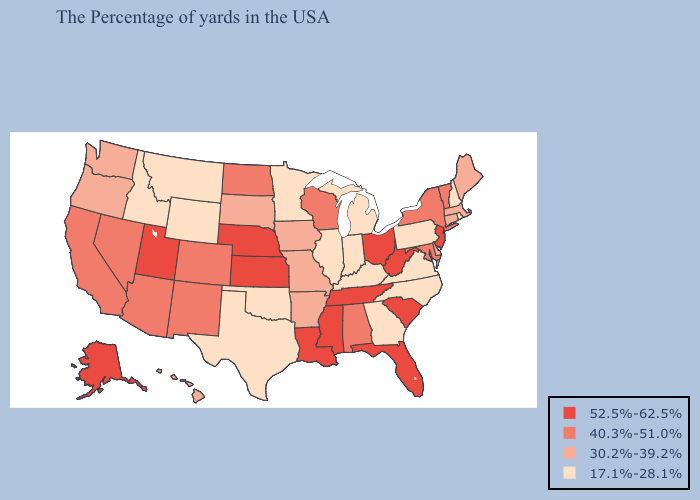Does the first symbol in the legend represent the smallest category?
Concise answer only. No. Name the states that have a value in the range 40.3%-51.0%?
Concise answer only. Vermont, New York, Maryland, Alabama, Wisconsin, North Dakota, Colorado, New Mexico, Arizona, Nevada, California. Name the states that have a value in the range 40.3%-51.0%?
Keep it brief. Vermont, New York, Maryland, Alabama, Wisconsin, North Dakota, Colorado, New Mexico, Arizona, Nevada, California. Does Indiana have the same value as Washington?
Concise answer only. No. Name the states that have a value in the range 17.1%-28.1%?
Answer briefly. Rhode Island, New Hampshire, Pennsylvania, Virginia, North Carolina, Georgia, Michigan, Kentucky, Indiana, Illinois, Minnesota, Oklahoma, Texas, Wyoming, Montana, Idaho. Name the states that have a value in the range 30.2%-39.2%?
Concise answer only. Maine, Massachusetts, Connecticut, Delaware, Missouri, Arkansas, Iowa, South Dakota, Washington, Oregon, Hawaii. Among the states that border Utah , does Wyoming have the highest value?
Quick response, please. No. What is the value of Nebraska?
Short answer required. 52.5%-62.5%. What is the value of West Virginia?
Be succinct. 52.5%-62.5%. Name the states that have a value in the range 17.1%-28.1%?
Quick response, please. Rhode Island, New Hampshire, Pennsylvania, Virginia, North Carolina, Georgia, Michigan, Kentucky, Indiana, Illinois, Minnesota, Oklahoma, Texas, Wyoming, Montana, Idaho. Name the states that have a value in the range 40.3%-51.0%?
Concise answer only. Vermont, New York, Maryland, Alabama, Wisconsin, North Dakota, Colorado, New Mexico, Arizona, Nevada, California. What is the value of Utah?
Concise answer only. 52.5%-62.5%. Among the states that border Iowa , does Nebraska have the highest value?
Answer briefly. Yes. Among the states that border Michigan , which have the lowest value?
Keep it brief. Indiana. Does the map have missing data?
Give a very brief answer. No. 